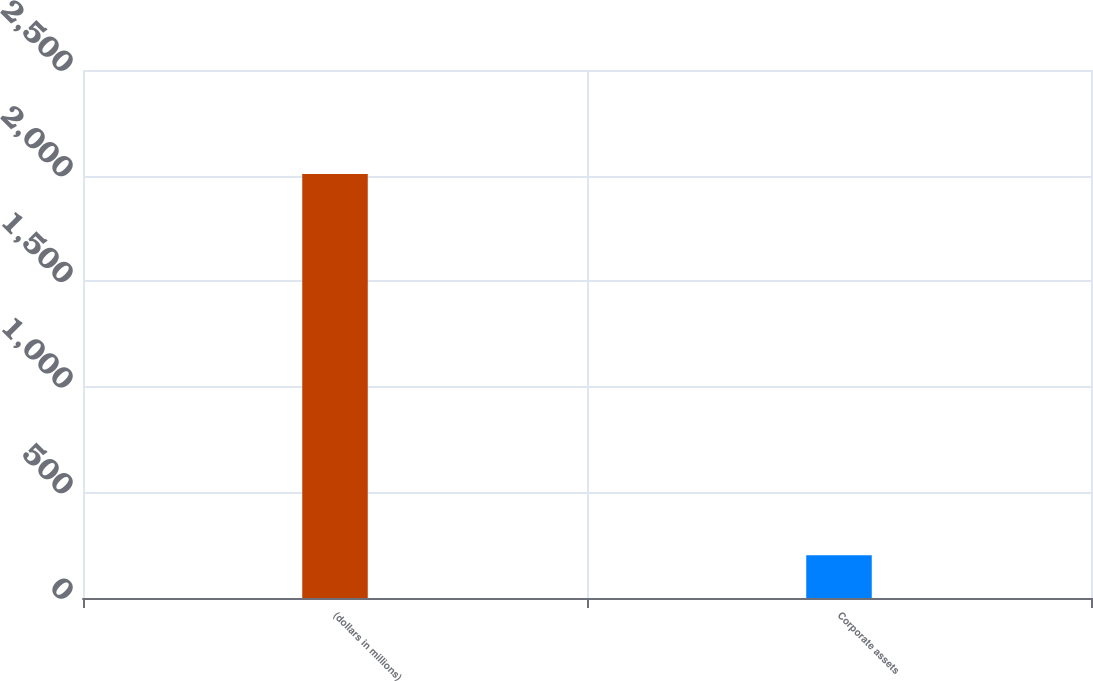<chart> <loc_0><loc_0><loc_500><loc_500><bar_chart><fcel>(dollars in millions)<fcel>Corporate assets<nl><fcel>2008<fcel>202.5<nl></chart> 